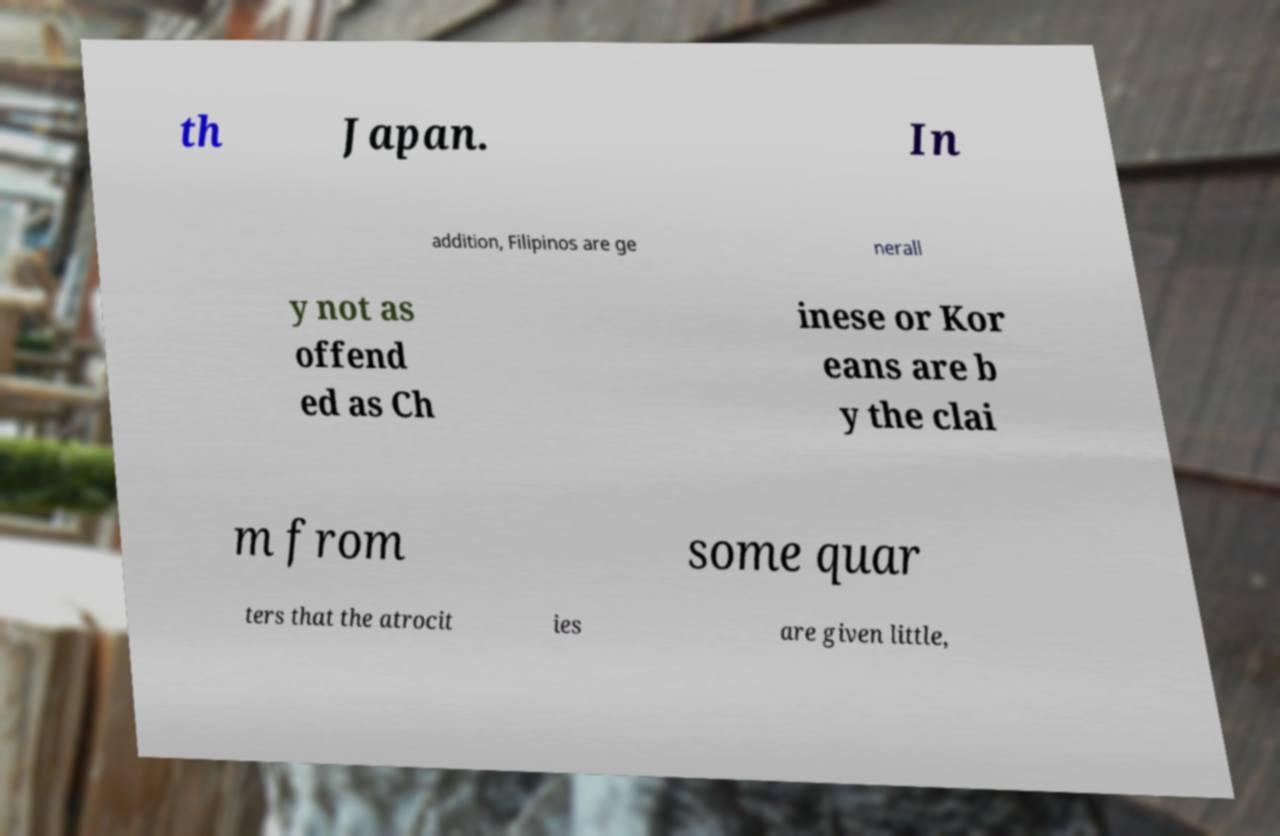Please read and relay the text visible in this image. What does it say? th Japan. In addition, Filipinos are ge nerall y not as offend ed as Ch inese or Kor eans are b y the clai m from some quar ters that the atrocit ies are given little, 